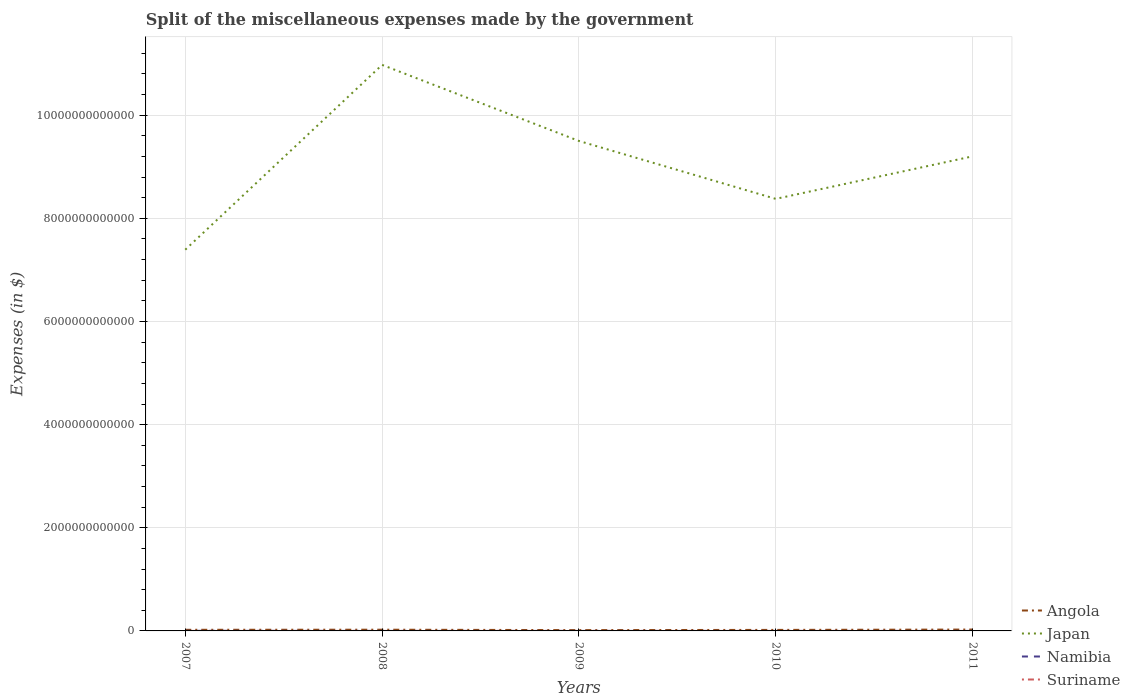Does the line corresponding to Japan intersect with the line corresponding to Namibia?
Keep it short and to the point. No. Is the number of lines equal to the number of legend labels?
Ensure brevity in your answer.  Yes. Across all years, what is the maximum miscellaneous expenses made by the government in Namibia?
Keep it short and to the point. 3.22e+07. In which year was the miscellaneous expenses made by the government in Angola maximum?
Make the answer very short. 2009. What is the total miscellaneous expenses made by the government in Namibia in the graph?
Provide a succinct answer. 1.84e+09. What is the difference between the highest and the second highest miscellaneous expenses made by the government in Namibia?
Your answer should be very brief. 2.04e+09. What is the difference between the highest and the lowest miscellaneous expenses made by the government in Suriname?
Make the answer very short. 2. Is the miscellaneous expenses made by the government in Japan strictly greater than the miscellaneous expenses made by the government in Namibia over the years?
Make the answer very short. No. How many lines are there?
Ensure brevity in your answer.  4. How many years are there in the graph?
Make the answer very short. 5. What is the difference between two consecutive major ticks on the Y-axis?
Your answer should be very brief. 2.00e+12. Does the graph contain grids?
Keep it short and to the point. Yes. How many legend labels are there?
Give a very brief answer. 4. What is the title of the graph?
Give a very brief answer. Split of the miscellaneous expenses made by the government. Does "Cayman Islands" appear as one of the legend labels in the graph?
Ensure brevity in your answer.  No. What is the label or title of the X-axis?
Offer a very short reply. Years. What is the label or title of the Y-axis?
Make the answer very short. Expenses (in $). What is the Expenses (in $) in Angola in 2007?
Your response must be concise. 2.19e+1. What is the Expenses (in $) in Japan in 2007?
Your answer should be very brief. 7.39e+12. What is the Expenses (in $) in Namibia in 2007?
Offer a very short reply. 2.07e+09. What is the Expenses (in $) of Suriname in 2007?
Offer a very short reply. 1.57e+08. What is the Expenses (in $) of Angola in 2008?
Your answer should be very brief. 2.38e+1. What is the Expenses (in $) in Japan in 2008?
Your answer should be compact. 1.10e+13. What is the Expenses (in $) of Namibia in 2008?
Offer a very short reply. 2.55e+08. What is the Expenses (in $) of Suriname in 2008?
Your answer should be very brief. 2.44e+08. What is the Expenses (in $) in Angola in 2009?
Your answer should be compact. 1.59e+1. What is the Expenses (in $) in Japan in 2009?
Offer a very short reply. 9.50e+12. What is the Expenses (in $) in Namibia in 2009?
Your response must be concise. 2.30e+08. What is the Expenses (in $) of Suriname in 2009?
Offer a terse response. 2.15e+08. What is the Expenses (in $) in Angola in 2010?
Offer a very short reply. 1.98e+1. What is the Expenses (in $) of Japan in 2010?
Make the answer very short. 8.38e+12. What is the Expenses (in $) of Namibia in 2010?
Offer a terse response. 3.22e+07. What is the Expenses (in $) in Suriname in 2010?
Your answer should be compact. 1.49e+08. What is the Expenses (in $) of Angola in 2011?
Ensure brevity in your answer.  2.66e+1. What is the Expenses (in $) in Japan in 2011?
Keep it short and to the point. 9.20e+12. What is the Expenses (in $) in Namibia in 2011?
Your answer should be compact. 2.60e+08. What is the Expenses (in $) in Suriname in 2011?
Your response must be concise. 1.15e+08. Across all years, what is the maximum Expenses (in $) of Angola?
Ensure brevity in your answer.  2.66e+1. Across all years, what is the maximum Expenses (in $) of Japan?
Provide a succinct answer. 1.10e+13. Across all years, what is the maximum Expenses (in $) of Namibia?
Your answer should be compact. 2.07e+09. Across all years, what is the maximum Expenses (in $) of Suriname?
Offer a terse response. 2.44e+08. Across all years, what is the minimum Expenses (in $) in Angola?
Offer a terse response. 1.59e+1. Across all years, what is the minimum Expenses (in $) in Japan?
Your answer should be compact. 7.39e+12. Across all years, what is the minimum Expenses (in $) in Namibia?
Offer a terse response. 3.22e+07. Across all years, what is the minimum Expenses (in $) in Suriname?
Keep it short and to the point. 1.15e+08. What is the total Expenses (in $) of Angola in the graph?
Offer a terse response. 1.08e+11. What is the total Expenses (in $) in Japan in the graph?
Make the answer very short. 4.54e+13. What is the total Expenses (in $) in Namibia in the graph?
Your answer should be very brief. 2.85e+09. What is the total Expenses (in $) of Suriname in the graph?
Offer a very short reply. 8.80e+08. What is the difference between the Expenses (in $) in Angola in 2007 and that in 2008?
Your answer should be very brief. -1.88e+09. What is the difference between the Expenses (in $) in Japan in 2007 and that in 2008?
Ensure brevity in your answer.  -3.58e+12. What is the difference between the Expenses (in $) of Namibia in 2007 and that in 2008?
Your response must be concise. 1.82e+09. What is the difference between the Expenses (in $) of Suriname in 2007 and that in 2008?
Your response must be concise. -8.65e+07. What is the difference between the Expenses (in $) in Angola in 2007 and that in 2009?
Offer a very short reply. 5.95e+09. What is the difference between the Expenses (in $) in Japan in 2007 and that in 2009?
Offer a very short reply. -2.11e+12. What is the difference between the Expenses (in $) of Namibia in 2007 and that in 2009?
Provide a succinct answer. 1.84e+09. What is the difference between the Expenses (in $) in Suriname in 2007 and that in 2009?
Provide a succinct answer. -5.77e+07. What is the difference between the Expenses (in $) of Angola in 2007 and that in 2010?
Your answer should be very brief. 2.07e+09. What is the difference between the Expenses (in $) in Japan in 2007 and that in 2010?
Provide a short and direct response. -9.86e+11. What is the difference between the Expenses (in $) of Namibia in 2007 and that in 2010?
Your answer should be compact. 2.04e+09. What is the difference between the Expenses (in $) of Suriname in 2007 and that in 2010?
Offer a terse response. 7.95e+06. What is the difference between the Expenses (in $) of Angola in 2007 and that in 2011?
Give a very brief answer. -4.73e+09. What is the difference between the Expenses (in $) of Japan in 2007 and that in 2011?
Ensure brevity in your answer.  -1.81e+12. What is the difference between the Expenses (in $) in Namibia in 2007 and that in 2011?
Keep it short and to the point. 1.81e+09. What is the difference between the Expenses (in $) in Suriname in 2007 and that in 2011?
Provide a succinct answer. 4.17e+07. What is the difference between the Expenses (in $) in Angola in 2008 and that in 2009?
Your answer should be very brief. 7.83e+09. What is the difference between the Expenses (in $) of Japan in 2008 and that in 2009?
Your answer should be compact. 1.48e+12. What is the difference between the Expenses (in $) of Namibia in 2008 and that in 2009?
Provide a short and direct response. 2.59e+07. What is the difference between the Expenses (in $) of Suriname in 2008 and that in 2009?
Provide a succinct answer. 2.88e+07. What is the difference between the Expenses (in $) in Angola in 2008 and that in 2010?
Offer a terse response. 3.95e+09. What is the difference between the Expenses (in $) of Japan in 2008 and that in 2010?
Your answer should be compact. 2.60e+12. What is the difference between the Expenses (in $) of Namibia in 2008 and that in 2010?
Provide a short and direct response. 2.23e+08. What is the difference between the Expenses (in $) of Suriname in 2008 and that in 2010?
Ensure brevity in your answer.  9.44e+07. What is the difference between the Expenses (in $) of Angola in 2008 and that in 2011?
Provide a short and direct response. -2.84e+09. What is the difference between the Expenses (in $) in Japan in 2008 and that in 2011?
Offer a very short reply. 1.77e+12. What is the difference between the Expenses (in $) of Namibia in 2008 and that in 2011?
Your answer should be compact. -4.06e+06. What is the difference between the Expenses (in $) in Suriname in 2008 and that in 2011?
Ensure brevity in your answer.  1.28e+08. What is the difference between the Expenses (in $) of Angola in 2009 and that in 2010?
Offer a very short reply. -3.88e+09. What is the difference between the Expenses (in $) of Japan in 2009 and that in 2010?
Offer a very short reply. 1.12e+12. What is the difference between the Expenses (in $) in Namibia in 2009 and that in 2010?
Offer a very short reply. 1.97e+08. What is the difference between the Expenses (in $) in Suriname in 2009 and that in 2010?
Provide a succinct answer. 6.56e+07. What is the difference between the Expenses (in $) of Angola in 2009 and that in 2011?
Your answer should be compact. -1.07e+1. What is the difference between the Expenses (in $) of Japan in 2009 and that in 2011?
Make the answer very short. 2.98e+11. What is the difference between the Expenses (in $) of Namibia in 2009 and that in 2011?
Your answer should be compact. -2.99e+07. What is the difference between the Expenses (in $) in Suriname in 2009 and that in 2011?
Offer a very short reply. 9.94e+07. What is the difference between the Expenses (in $) of Angola in 2010 and that in 2011?
Ensure brevity in your answer.  -6.79e+09. What is the difference between the Expenses (in $) in Japan in 2010 and that in 2011?
Give a very brief answer. -8.24e+11. What is the difference between the Expenses (in $) in Namibia in 2010 and that in 2011?
Ensure brevity in your answer.  -2.27e+08. What is the difference between the Expenses (in $) in Suriname in 2010 and that in 2011?
Provide a short and direct response. 3.38e+07. What is the difference between the Expenses (in $) of Angola in 2007 and the Expenses (in $) of Japan in 2008?
Offer a terse response. -1.10e+13. What is the difference between the Expenses (in $) of Angola in 2007 and the Expenses (in $) of Namibia in 2008?
Make the answer very short. 2.16e+1. What is the difference between the Expenses (in $) in Angola in 2007 and the Expenses (in $) in Suriname in 2008?
Ensure brevity in your answer.  2.16e+1. What is the difference between the Expenses (in $) in Japan in 2007 and the Expenses (in $) in Namibia in 2008?
Make the answer very short. 7.39e+12. What is the difference between the Expenses (in $) in Japan in 2007 and the Expenses (in $) in Suriname in 2008?
Your response must be concise. 7.39e+12. What is the difference between the Expenses (in $) of Namibia in 2007 and the Expenses (in $) of Suriname in 2008?
Ensure brevity in your answer.  1.83e+09. What is the difference between the Expenses (in $) in Angola in 2007 and the Expenses (in $) in Japan in 2009?
Make the answer very short. -9.48e+12. What is the difference between the Expenses (in $) in Angola in 2007 and the Expenses (in $) in Namibia in 2009?
Provide a short and direct response. 2.16e+1. What is the difference between the Expenses (in $) in Angola in 2007 and the Expenses (in $) in Suriname in 2009?
Your response must be concise. 2.17e+1. What is the difference between the Expenses (in $) in Japan in 2007 and the Expenses (in $) in Namibia in 2009?
Your answer should be compact. 7.39e+12. What is the difference between the Expenses (in $) of Japan in 2007 and the Expenses (in $) of Suriname in 2009?
Ensure brevity in your answer.  7.39e+12. What is the difference between the Expenses (in $) of Namibia in 2007 and the Expenses (in $) of Suriname in 2009?
Your answer should be compact. 1.86e+09. What is the difference between the Expenses (in $) of Angola in 2007 and the Expenses (in $) of Japan in 2010?
Provide a short and direct response. -8.36e+12. What is the difference between the Expenses (in $) in Angola in 2007 and the Expenses (in $) in Namibia in 2010?
Give a very brief answer. 2.18e+1. What is the difference between the Expenses (in $) in Angola in 2007 and the Expenses (in $) in Suriname in 2010?
Give a very brief answer. 2.17e+1. What is the difference between the Expenses (in $) in Japan in 2007 and the Expenses (in $) in Namibia in 2010?
Offer a very short reply. 7.39e+12. What is the difference between the Expenses (in $) in Japan in 2007 and the Expenses (in $) in Suriname in 2010?
Keep it short and to the point. 7.39e+12. What is the difference between the Expenses (in $) in Namibia in 2007 and the Expenses (in $) in Suriname in 2010?
Keep it short and to the point. 1.92e+09. What is the difference between the Expenses (in $) of Angola in 2007 and the Expenses (in $) of Japan in 2011?
Ensure brevity in your answer.  -9.18e+12. What is the difference between the Expenses (in $) of Angola in 2007 and the Expenses (in $) of Namibia in 2011?
Keep it short and to the point. 2.16e+1. What is the difference between the Expenses (in $) in Angola in 2007 and the Expenses (in $) in Suriname in 2011?
Your response must be concise. 2.18e+1. What is the difference between the Expenses (in $) of Japan in 2007 and the Expenses (in $) of Namibia in 2011?
Offer a very short reply. 7.39e+12. What is the difference between the Expenses (in $) of Japan in 2007 and the Expenses (in $) of Suriname in 2011?
Your answer should be compact. 7.39e+12. What is the difference between the Expenses (in $) of Namibia in 2007 and the Expenses (in $) of Suriname in 2011?
Offer a terse response. 1.96e+09. What is the difference between the Expenses (in $) of Angola in 2008 and the Expenses (in $) of Japan in 2009?
Offer a terse response. -9.48e+12. What is the difference between the Expenses (in $) of Angola in 2008 and the Expenses (in $) of Namibia in 2009?
Your answer should be compact. 2.35e+1. What is the difference between the Expenses (in $) of Angola in 2008 and the Expenses (in $) of Suriname in 2009?
Your answer should be compact. 2.35e+1. What is the difference between the Expenses (in $) of Japan in 2008 and the Expenses (in $) of Namibia in 2009?
Your response must be concise. 1.10e+13. What is the difference between the Expenses (in $) in Japan in 2008 and the Expenses (in $) in Suriname in 2009?
Offer a very short reply. 1.10e+13. What is the difference between the Expenses (in $) in Namibia in 2008 and the Expenses (in $) in Suriname in 2009?
Offer a terse response. 4.07e+07. What is the difference between the Expenses (in $) of Angola in 2008 and the Expenses (in $) of Japan in 2010?
Keep it short and to the point. -8.35e+12. What is the difference between the Expenses (in $) in Angola in 2008 and the Expenses (in $) in Namibia in 2010?
Provide a succinct answer. 2.37e+1. What is the difference between the Expenses (in $) in Angola in 2008 and the Expenses (in $) in Suriname in 2010?
Make the answer very short. 2.36e+1. What is the difference between the Expenses (in $) in Japan in 2008 and the Expenses (in $) in Namibia in 2010?
Ensure brevity in your answer.  1.10e+13. What is the difference between the Expenses (in $) in Japan in 2008 and the Expenses (in $) in Suriname in 2010?
Your response must be concise. 1.10e+13. What is the difference between the Expenses (in $) of Namibia in 2008 and the Expenses (in $) of Suriname in 2010?
Make the answer very short. 1.06e+08. What is the difference between the Expenses (in $) in Angola in 2008 and the Expenses (in $) in Japan in 2011?
Make the answer very short. -9.18e+12. What is the difference between the Expenses (in $) of Angola in 2008 and the Expenses (in $) of Namibia in 2011?
Offer a terse response. 2.35e+1. What is the difference between the Expenses (in $) in Angola in 2008 and the Expenses (in $) in Suriname in 2011?
Ensure brevity in your answer.  2.36e+1. What is the difference between the Expenses (in $) in Japan in 2008 and the Expenses (in $) in Namibia in 2011?
Provide a succinct answer. 1.10e+13. What is the difference between the Expenses (in $) of Japan in 2008 and the Expenses (in $) of Suriname in 2011?
Give a very brief answer. 1.10e+13. What is the difference between the Expenses (in $) in Namibia in 2008 and the Expenses (in $) in Suriname in 2011?
Your answer should be compact. 1.40e+08. What is the difference between the Expenses (in $) in Angola in 2009 and the Expenses (in $) in Japan in 2010?
Offer a terse response. -8.36e+12. What is the difference between the Expenses (in $) in Angola in 2009 and the Expenses (in $) in Namibia in 2010?
Make the answer very short. 1.59e+1. What is the difference between the Expenses (in $) of Angola in 2009 and the Expenses (in $) of Suriname in 2010?
Keep it short and to the point. 1.58e+1. What is the difference between the Expenses (in $) in Japan in 2009 and the Expenses (in $) in Namibia in 2010?
Your answer should be compact. 9.50e+12. What is the difference between the Expenses (in $) in Japan in 2009 and the Expenses (in $) in Suriname in 2010?
Give a very brief answer. 9.50e+12. What is the difference between the Expenses (in $) of Namibia in 2009 and the Expenses (in $) of Suriname in 2010?
Your response must be concise. 8.04e+07. What is the difference between the Expenses (in $) in Angola in 2009 and the Expenses (in $) in Japan in 2011?
Ensure brevity in your answer.  -9.19e+12. What is the difference between the Expenses (in $) of Angola in 2009 and the Expenses (in $) of Namibia in 2011?
Provide a succinct answer. 1.57e+1. What is the difference between the Expenses (in $) in Angola in 2009 and the Expenses (in $) in Suriname in 2011?
Ensure brevity in your answer.  1.58e+1. What is the difference between the Expenses (in $) in Japan in 2009 and the Expenses (in $) in Namibia in 2011?
Give a very brief answer. 9.50e+12. What is the difference between the Expenses (in $) in Japan in 2009 and the Expenses (in $) in Suriname in 2011?
Your answer should be very brief. 9.50e+12. What is the difference between the Expenses (in $) of Namibia in 2009 and the Expenses (in $) of Suriname in 2011?
Offer a terse response. 1.14e+08. What is the difference between the Expenses (in $) of Angola in 2010 and the Expenses (in $) of Japan in 2011?
Provide a short and direct response. -9.18e+12. What is the difference between the Expenses (in $) in Angola in 2010 and the Expenses (in $) in Namibia in 2011?
Offer a very short reply. 1.95e+1. What is the difference between the Expenses (in $) in Angola in 2010 and the Expenses (in $) in Suriname in 2011?
Keep it short and to the point. 1.97e+1. What is the difference between the Expenses (in $) in Japan in 2010 and the Expenses (in $) in Namibia in 2011?
Make the answer very short. 8.38e+12. What is the difference between the Expenses (in $) of Japan in 2010 and the Expenses (in $) of Suriname in 2011?
Your answer should be very brief. 8.38e+12. What is the difference between the Expenses (in $) in Namibia in 2010 and the Expenses (in $) in Suriname in 2011?
Give a very brief answer. -8.32e+07. What is the average Expenses (in $) of Angola per year?
Provide a short and direct response. 2.16e+1. What is the average Expenses (in $) of Japan per year?
Make the answer very short. 9.09e+12. What is the average Expenses (in $) in Namibia per year?
Give a very brief answer. 5.70e+08. What is the average Expenses (in $) in Suriname per year?
Keep it short and to the point. 1.76e+08. In the year 2007, what is the difference between the Expenses (in $) of Angola and Expenses (in $) of Japan?
Ensure brevity in your answer.  -7.37e+12. In the year 2007, what is the difference between the Expenses (in $) of Angola and Expenses (in $) of Namibia?
Your response must be concise. 1.98e+1. In the year 2007, what is the difference between the Expenses (in $) of Angola and Expenses (in $) of Suriname?
Make the answer very short. 2.17e+1. In the year 2007, what is the difference between the Expenses (in $) in Japan and Expenses (in $) in Namibia?
Offer a terse response. 7.39e+12. In the year 2007, what is the difference between the Expenses (in $) of Japan and Expenses (in $) of Suriname?
Your answer should be very brief. 7.39e+12. In the year 2007, what is the difference between the Expenses (in $) of Namibia and Expenses (in $) of Suriname?
Give a very brief answer. 1.92e+09. In the year 2008, what is the difference between the Expenses (in $) of Angola and Expenses (in $) of Japan?
Make the answer very short. -1.10e+13. In the year 2008, what is the difference between the Expenses (in $) in Angola and Expenses (in $) in Namibia?
Your response must be concise. 2.35e+1. In the year 2008, what is the difference between the Expenses (in $) in Angola and Expenses (in $) in Suriname?
Your answer should be very brief. 2.35e+1. In the year 2008, what is the difference between the Expenses (in $) in Japan and Expenses (in $) in Namibia?
Give a very brief answer. 1.10e+13. In the year 2008, what is the difference between the Expenses (in $) of Japan and Expenses (in $) of Suriname?
Keep it short and to the point. 1.10e+13. In the year 2008, what is the difference between the Expenses (in $) in Namibia and Expenses (in $) in Suriname?
Offer a terse response. 1.19e+07. In the year 2009, what is the difference between the Expenses (in $) in Angola and Expenses (in $) in Japan?
Offer a terse response. -9.48e+12. In the year 2009, what is the difference between the Expenses (in $) of Angola and Expenses (in $) of Namibia?
Offer a terse response. 1.57e+1. In the year 2009, what is the difference between the Expenses (in $) in Angola and Expenses (in $) in Suriname?
Provide a succinct answer. 1.57e+1. In the year 2009, what is the difference between the Expenses (in $) of Japan and Expenses (in $) of Namibia?
Your answer should be compact. 9.50e+12. In the year 2009, what is the difference between the Expenses (in $) of Japan and Expenses (in $) of Suriname?
Provide a succinct answer. 9.50e+12. In the year 2009, what is the difference between the Expenses (in $) of Namibia and Expenses (in $) of Suriname?
Your answer should be very brief. 1.48e+07. In the year 2010, what is the difference between the Expenses (in $) of Angola and Expenses (in $) of Japan?
Offer a terse response. -8.36e+12. In the year 2010, what is the difference between the Expenses (in $) of Angola and Expenses (in $) of Namibia?
Make the answer very short. 1.98e+1. In the year 2010, what is the difference between the Expenses (in $) of Angola and Expenses (in $) of Suriname?
Make the answer very short. 1.97e+1. In the year 2010, what is the difference between the Expenses (in $) of Japan and Expenses (in $) of Namibia?
Your response must be concise. 8.38e+12. In the year 2010, what is the difference between the Expenses (in $) in Japan and Expenses (in $) in Suriname?
Make the answer very short. 8.38e+12. In the year 2010, what is the difference between the Expenses (in $) in Namibia and Expenses (in $) in Suriname?
Your answer should be very brief. -1.17e+08. In the year 2011, what is the difference between the Expenses (in $) in Angola and Expenses (in $) in Japan?
Keep it short and to the point. -9.18e+12. In the year 2011, what is the difference between the Expenses (in $) of Angola and Expenses (in $) of Namibia?
Offer a very short reply. 2.63e+1. In the year 2011, what is the difference between the Expenses (in $) of Angola and Expenses (in $) of Suriname?
Provide a short and direct response. 2.65e+1. In the year 2011, what is the difference between the Expenses (in $) in Japan and Expenses (in $) in Namibia?
Offer a terse response. 9.20e+12. In the year 2011, what is the difference between the Expenses (in $) of Japan and Expenses (in $) of Suriname?
Give a very brief answer. 9.20e+12. In the year 2011, what is the difference between the Expenses (in $) of Namibia and Expenses (in $) of Suriname?
Provide a short and direct response. 1.44e+08. What is the ratio of the Expenses (in $) in Angola in 2007 to that in 2008?
Keep it short and to the point. 0.92. What is the ratio of the Expenses (in $) of Japan in 2007 to that in 2008?
Make the answer very short. 0.67. What is the ratio of the Expenses (in $) in Namibia in 2007 to that in 2008?
Your answer should be compact. 8.12. What is the ratio of the Expenses (in $) of Suriname in 2007 to that in 2008?
Provide a succinct answer. 0.65. What is the ratio of the Expenses (in $) of Angola in 2007 to that in 2009?
Make the answer very short. 1.37. What is the ratio of the Expenses (in $) of Japan in 2007 to that in 2009?
Your answer should be compact. 0.78. What is the ratio of the Expenses (in $) in Namibia in 2007 to that in 2009?
Your response must be concise. 9.03. What is the ratio of the Expenses (in $) in Suriname in 2007 to that in 2009?
Provide a succinct answer. 0.73. What is the ratio of the Expenses (in $) of Angola in 2007 to that in 2010?
Make the answer very short. 1.1. What is the ratio of the Expenses (in $) of Japan in 2007 to that in 2010?
Your answer should be very brief. 0.88. What is the ratio of the Expenses (in $) in Namibia in 2007 to that in 2010?
Offer a terse response. 64.43. What is the ratio of the Expenses (in $) in Suriname in 2007 to that in 2010?
Keep it short and to the point. 1.05. What is the ratio of the Expenses (in $) of Angola in 2007 to that in 2011?
Give a very brief answer. 0.82. What is the ratio of the Expenses (in $) in Japan in 2007 to that in 2011?
Provide a short and direct response. 0.8. What is the ratio of the Expenses (in $) of Namibia in 2007 to that in 2011?
Your answer should be compact. 7.99. What is the ratio of the Expenses (in $) in Suriname in 2007 to that in 2011?
Your answer should be very brief. 1.36. What is the ratio of the Expenses (in $) of Angola in 2008 to that in 2009?
Give a very brief answer. 1.49. What is the ratio of the Expenses (in $) of Japan in 2008 to that in 2009?
Offer a very short reply. 1.16. What is the ratio of the Expenses (in $) of Namibia in 2008 to that in 2009?
Give a very brief answer. 1.11. What is the ratio of the Expenses (in $) in Suriname in 2008 to that in 2009?
Offer a terse response. 1.13. What is the ratio of the Expenses (in $) of Angola in 2008 to that in 2010?
Ensure brevity in your answer.  1.2. What is the ratio of the Expenses (in $) in Japan in 2008 to that in 2010?
Provide a succinct answer. 1.31. What is the ratio of the Expenses (in $) of Namibia in 2008 to that in 2010?
Provide a short and direct response. 7.94. What is the ratio of the Expenses (in $) of Suriname in 2008 to that in 2010?
Keep it short and to the point. 1.63. What is the ratio of the Expenses (in $) in Angola in 2008 to that in 2011?
Make the answer very short. 0.89. What is the ratio of the Expenses (in $) in Japan in 2008 to that in 2011?
Ensure brevity in your answer.  1.19. What is the ratio of the Expenses (in $) in Namibia in 2008 to that in 2011?
Your answer should be very brief. 0.98. What is the ratio of the Expenses (in $) in Suriname in 2008 to that in 2011?
Make the answer very short. 2.11. What is the ratio of the Expenses (in $) in Angola in 2009 to that in 2010?
Keep it short and to the point. 0.8. What is the ratio of the Expenses (in $) in Japan in 2009 to that in 2010?
Give a very brief answer. 1.13. What is the ratio of the Expenses (in $) of Namibia in 2009 to that in 2010?
Give a very brief answer. 7.13. What is the ratio of the Expenses (in $) in Suriname in 2009 to that in 2010?
Offer a terse response. 1.44. What is the ratio of the Expenses (in $) in Angola in 2009 to that in 2011?
Your answer should be very brief. 0.6. What is the ratio of the Expenses (in $) in Japan in 2009 to that in 2011?
Your answer should be very brief. 1.03. What is the ratio of the Expenses (in $) of Namibia in 2009 to that in 2011?
Offer a terse response. 0.88. What is the ratio of the Expenses (in $) in Suriname in 2009 to that in 2011?
Your response must be concise. 1.86. What is the ratio of the Expenses (in $) in Angola in 2010 to that in 2011?
Provide a short and direct response. 0.74. What is the ratio of the Expenses (in $) in Japan in 2010 to that in 2011?
Ensure brevity in your answer.  0.91. What is the ratio of the Expenses (in $) in Namibia in 2010 to that in 2011?
Your answer should be compact. 0.12. What is the ratio of the Expenses (in $) of Suriname in 2010 to that in 2011?
Provide a short and direct response. 1.29. What is the difference between the highest and the second highest Expenses (in $) of Angola?
Keep it short and to the point. 2.84e+09. What is the difference between the highest and the second highest Expenses (in $) in Japan?
Your answer should be compact. 1.48e+12. What is the difference between the highest and the second highest Expenses (in $) in Namibia?
Ensure brevity in your answer.  1.81e+09. What is the difference between the highest and the second highest Expenses (in $) in Suriname?
Your response must be concise. 2.88e+07. What is the difference between the highest and the lowest Expenses (in $) of Angola?
Make the answer very short. 1.07e+1. What is the difference between the highest and the lowest Expenses (in $) of Japan?
Keep it short and to the point. 3.58e+12. What is the difference between the highest and the lowest Expenses (in $) of Namibia?
Provide a short and direct response. 2.04e+09. What is the difference between the highest and the lowest Expenses (in $) in Suriname?
Make the answer very short. 1.28e+08. 